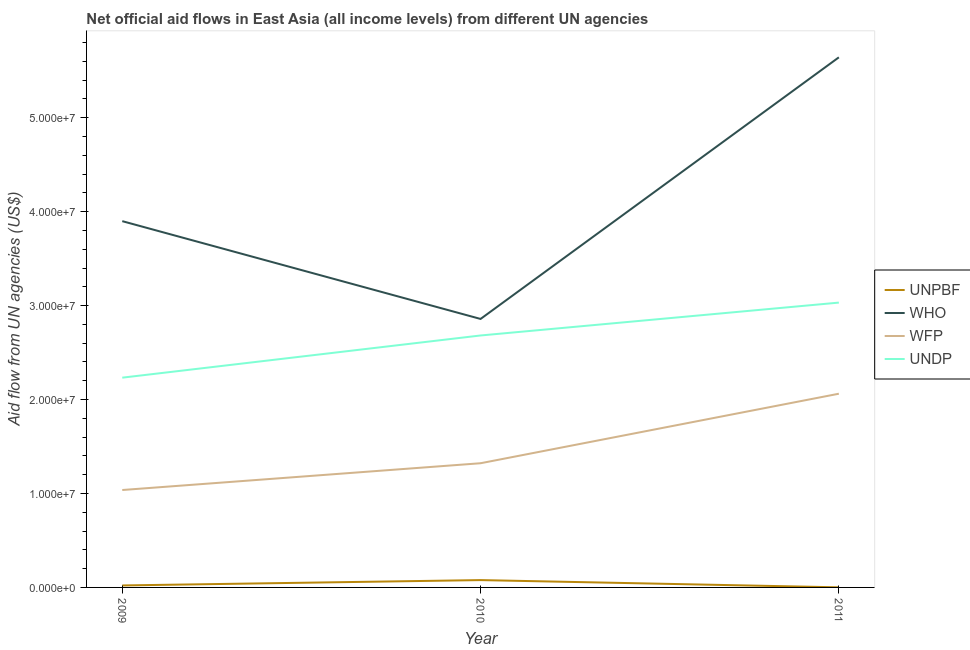Is the number of lines equal to the number of legend labels?
Your answer should be compact. Yes. What is the amount of aid given by wfp in 2011?
Offer a very short reply. 2.06e+07. Across all years, what is the maximum amount of aid given by who?
Provide a short and direct response. 5.64e+07. Across all years, what is the minimum amount of aid given by undp?
Make the answer very short. 2.23e+07. In which year was the amount of aid given by unpbf minimum?
Provide a short and direct response. 2011. What is the total amount of aid given by wfp in the graph?
Keep it short and to the point. 4.42e+07. What is the difference between the amount of aid given by unpbf in 2009 and that in 2011?
Keep it short and to the point. 2.00e+05. What is the difference between the amount of aid given by undp in 2009 and the amount of aid given by who in 2010?
Give a very brief answer. -6.25e+06. What is the average amount of aid given by unpbf per year?
Your response must be concise. 3.33e+05. In the year 2009, what is the difference between the amount of aid given by who and amount of aid given by unpbf?
Give a very brief answer. 3.88e+07. In how many years, is the amount of aid given by unpbf greater than 44000000 US$?
Give a very brief answer. 0. What is the ratio of the amount of aid given by who in 2009 to that in 2011?
Your response must be concise. 0.69. Is the amount of aid given by wfp in 2009 less than that in 2011?
Ensure brevity in your answer.  Yes. Is the difference between the amount of aid given by wfp in 2009 and 2011 greater than the difference between the amount of aid given by unpbf in 2009 and 2011?
Provide a succinct answer. No. What is the difference between the highest and the second highest amount of aid given by who?
Ensure brevity in your answer.  1.74e+07. What is the difference between the highest and the lowest amount of aid given by undp?
Make the answer very short. 7.99e+06. Is it the case that in every year, the sum of the amount of aid given by unpbf and amount of aid given by undp is greater than the sum of amount of aid given by who and amount of aid given by wfp?
Provide a short and direct response. Yes. Is it the case that in every year, the sum of the amount of aid given by unpbf and amount of aid given by who is greater than the amount of aid given by wfp?
Give a very brief answer. Yes. How many years are there in the graph?
Give a very brief answer. 3. What is the difference between two consecutive major ticks on the Y-axis?
Keep it short and to the point. 1.00e+07. Are the values on the major ticks of Y-axis written in scientific E-notation?
Ensure brevity in your answer.  Yes. Does the graph contain grids?
Offer a very short reply. No. Where does the legend appear in the graph?
Provide a succinct answer. Center right. How many legend labels are there?
Provide a succinct answer. 4. What is the title of the graph?
Your answer should be compact. Net official aid flows in East Asia (all income levels) from different UN agencies. What is the label or title of the X-axis?
Make the answer very short. Year. What is the label or title of the Y-axis?
Your response must be concise. Aid flow from UN agencies (US$). What is the Aid flow from UN agencies (US$) in WHO in 2009?
Provide a succinct answer. 3.90e+07. What is the Aid flow from UN agencies (US$) of WFP in 2009?
Provide a succinct answer. 1.04e+07. What is the Aid flow from UN agencies (US$) of UNDP in 2009?
Make the answer very short. 2.23e+07. What is the Aid flow from UN agencies (US$) in UNPBF in 2010?
Provide a short and direct response. 7.80e+05. What is the Aid flow from UN agencies (US$) of WHO in 2010?
Offer a very short reply. 2.86e+07. What is the Aid flow from UN agencies (US$) of WFP in 2010?
Your answer should be very brief. 1.32e+07. What is the Aid flow from UN agencies (US$) in UNDP in 2010?
Keep it short and to the point. 2.68e+07. What is the Aid flow from UN agencies (US$) of WHO in 2011?
Offer a very short reply. 5.64e+07. What is the Aid flow from UN agencies (US$) in WFP in 2011?
Offer a very short reply. 2.06e+07. What is the Aid flow from UN agencies (US$) of UNDP in 2011?
Provide a succinct answer. 3.03e+07. Across all years, what is the maximum Aid flow from UN agencies (US$) in UNPBF?
Offer a very short reply. 7.80e+05. Across all years, what is the maximum Aid flow from UN agencies (US$) in WHO?
Provide a short and direct response. 5.64e+07. Across all years, what is the maximum Aid flow from UN agencies (US$) of WFP?
Make the answer very short. 2.06e+07. Across all years, what is the maximum Aid flow from UN agencies (US$) of UNDP?
Provide a succinct answer. 3.03e+07. Across all years, what is the minimum Aid flow from UN agencies (US$) in UNPBF?
Provide a short and direct response. 10000. Across all years, what is the minimum Aid flow from UN agencies (US$) in WHO?
Make the answer very short. 2.86e+07. Across all years, what is the minimum Aid flow from UN agencies (US$) of WFP?
Your response must be concise. 1.04e+07. Across all years, what is the minimum Aid flow from UN agencies (US$) of UNDP?
Offer a very short reply. 2.23e+07. What is the total Aid flow from UN agencies (US$) of WHO in the graph?
Your answer should be compact. 1.24e+08. What is the total Aid flow from UN agencies (US$) in WFP in the graph?
Keep it short and to the point. 4.42e+07. What is the total Aid flow from UN agencies (US$) in UNDP in the graph?
Give a very brief answer. 7.95e+07. What is the difference between the Aid flow from UN agencies (US$) in UNPBF in 2009 and that in 2010?
Provide a short and direct response. -5.70e+05. What is the difference between the Aid flow from UN agencies (US$) in WHO in 2009 and that in 2010?
Your answer should be very brief. 1.04e+07. What is the difference between the Aid flow from UN agencies (US$) of WFP in 2009 and that in 2010?
Ensure brevity in your answer.  -2.85e+06. What is the difference between the Aid flow from UN agencies (US$) of UNDP in 2009 and that in 2010?
Provide a succinct answer. -4.49e+06. What is the difference between the Aid flow from UN agencies (US$) in UNPBF in 2009 and that in 2011?
Give a very brief answer. 2.00e+05. What is the difference between the Aid flow from UN agencies (US$) in WHO in 2009 and that in 2011?
Your response must be concise. -1.74e+07. What is the difference between the Aid flow from UN agencies (US$) in WFP in 2009 and that in 2011?
Keep it short and to the point. -1.02e+07. What is the difference between the Aid flow from UN agencies (US$) in UNDP in 2009 and that in 2011?
Provide a succinct answer. -7.99e+06. What is the difference between the Aid flow from UN agencies (US$) in UNPBF in 2010 and that in 2011?
Provide a short and direct response. 7.70e+05. What is the difference between the Aid flow from UN agencies (US$) of WHO in 2010 and that in 2011?
Keep it short and to the point. -2.78e+07. What is the difference between the Aid flow from UN agencies (US$) of WFP in 2010 and that in 2011?
Provide a short and direct response. -7.40e+06. What is the difference between the Aid flow from UN agencies (US$) of UNDP in 2010 and that in 2011?
Your response must be concise. -3.50e+06. What is the difference between the Aid flow from UN agencies (US$) in UNPBF in 2009 and the Aid flow from UN agencies (US$) in WHO in 2010?
Keep it short and to the point. -2.84e+07. What is the difference between the Aid flow from UN agencies (US$) in UNPBF in 2009 and the Aid flow from UN agencies (US$) in WFP in 2010?
Provide a succinct answer. -1.30e+07. What is the difference between the Aid flow from UN agencies (US$) of UNPBF in 2009 and the Aid flow from UN agencies (US$) of UNDP in 2010?
Your answer should be very brief. -2.66e+07. What is the difference between the Aid flow from UN agencies (US$) of WHO in 2009 and the Aid flow from UN agencies (US$) of WFP in 2010?
Your answer should be very brief. 2.58e+07. What is the difference between the Aid flow from UN agencies (US$) of WHO in 2009 and the Aid flow from UN agencies (US$) of UNDP in 2010?
Provide a short and direct response. 1.22e+07. What is the difference between the Aid flow from UN agencies (US$) in WFP in 2009 and the Aid flow from UN agencies (US$) in UNDP in 2010?
Ensure brevity in your answer.  -1.64e+07. What is the difference between the Aid flow from UN agencies (US$) of UNPBF in 2009 and the Aid flow from UN agencies (US$) of WHO in 2011?
Your answer should be very brief. -5.62e+07. What is the difference between the Aid flow from UN agencies (US$) of UNPBF in 2009 and the Aid flow from UN agencies (US$) of WFP in 2011?
Provide a short and direct response. -2.04e+07. What is the difference between the Aid flow from UN agencies (US$) in UNPBF in 2009 and the Aid flow from UN agencies (US$) in UNDP in 2011?
Offer a terse response. -3.01e+07. What is the difference between the Aid flow from UN agencies (US$) of WHO in 2009 and the Aid flow from UN agencies (US$) of WFP in 2011?
Provide a short and direct response. 1.84e+07. What is the difference between the Aid flow from UN agencies (US$) of WHO in 2009 and the Aid flow from UN agencies (US$) of UNDP in 2011?
Make the answer very short. 8.67e+06. What is the difference between the Aid flow from UN agencies (US$) in WFP in 2009 and the Aid flow from UN agencies (US$) in UNDP in 2011?
Provide a succinct answer. -2.00e+07. What is the difference between the Aid flow from UN agencies (US$) of UNPBF in 2010 and the Aid flow from UN agencies (US$) of WHO in 2011?
Your answer should be compact. -5.56e+07. What is the difference between the Aid flow from UN agencies (US$) in UNPBF in 2010 and the Aid flow from UN agencies (US$) in WFP in 2011?
Make the answer very short. -1.98e+07. What is the difference between the Aid flow from UN agencies (US$) of UNPBF in 2010 and the Aid flow from UN agencies (US$) of UNDP in 2011?
Make the answer very short. -2.95e+07. What is the difference between the Aid flow from UN agencies (US$) of WHO in 2010 and the Aid flow from UN agencies (US$) of WFP in 2011?
Provide a succinct answer. 7.96e+06. What is the difference between the Aid flow from UN agencies (US$) of WHO in 2010 and the Aid flow from UN agencies (US$) of UNDP in 2011?
Your response must be concise. -1.74e+06. What is the difference between the Aid flow from UN agencies (US$) of WFP in 2010 and the Aid flow from UN agencies (US$) of UNDP in 2011?
Keep it short and to the point. -1.71e+07. What is the average Aid flow from UN agencies (US$) of UNPBF per year?
Offer a very short reply. 3.33e+05. What is the average Aid flow from UN agencies (US$) in WHO per year?
Provide a short and direct response. 4.13e+07. What is the average Aid flow from UN agencies (US$) of WFP per year?
Your answer should be very brief. 1.47e+07. What is the average Aid flow from UN agencies (US$) in UNDP per year?
Your answer should be compact. 2.65e+07. In the year 2009, what is the difference between the Aid flow from UN agencies (US$) in UNPBF and Aid flow from UN agencies (US$) in WHO?
Provide a succinct answer. -3.88e+07. In the year 2009, what is the difference between the Aid flow from UN agencies (US$) of UNPBF and Aid flow from UN agencies (US$) of WFP?
Keep it short and to the point. -1.02e+07. In the year 2009, what is the difference between the Aid flow from UN agencies (US$) in UNPBF and Aid flow from UN agencies (US$) in UNDP?
Offer a very short reply. -2.21e+07. In the year 2009, what is the difference between the Aid flow from UN agencies (US$) in WHO and Aid flow from UN agencies (US$) in WFP?
Ensure brevity in your answer.  2.86e+07. In the year 2009, what is the difference between the Aid flow from UN agencies (US$) of WHO and Aid flow from UN agencies (US$) of UNDP?
Your answer should be very brief. 1.67e+07. In the year 2009, what is the difference between the Aid flow from UN agencies (US$) of WFP and Aid flow from UN agencies (US$) of UNDP?
Offer a very short reply. -1.20e+07. In the year 2010, what is the difference between the Aid flow from UN agencies (US$) in UNPBF and Aid flow from UN agencies (US$) in WHO?
Offer a terse response. -2.78e+07. In the year 2010, what is the difference between the Aid flow from UN agencies (US$) of UNPBF and Aid flow from UN agencies (US$) of WFP?
Your response must be concise. -1.24e+07. In the year 2010, what is the difference between the Aid flow from UN agencies (US$) in UNPBF and Aid flow from UN agencies (US$) in UNDP?
Offer a terse response. -2.60e+07. In the year 2010, what is the difference between the Aid flow from UN agencies (US$) of WHO and Aid flow from UN agencies (US$) of WFP?
Your answer should be compact. 1.54e+07. In the year 2010, what is the difference between the Aid flow from UN agencies (US$) of WHO and Aid flow from UN agencies (US$) of UNDP?
Ensure brevity in your answer.  1.76e+06. In the year 2010, what is the difference between the Aid flow from UN agencies (US$) of WFP and Aid flow from UN agencies (US$) of UNDP?
Provide a short and direct response. -1.36e+07. In the year 2011, what is the difference between the Aid flow from UN agencies (US$) in UNPBF and Aid flow from UN agencies (US$) in WHO?
Ensure brevity in your answer.  -5.64e+07. In the year 2011, what is the difference between the Aid flow from UN agencies (US$) in UNPBF and Aid flow from UN agencies (US$) in WFP?
Provide a succinct answer. -2.06e+07. In the year 2011, what is the difference between the Aid flow from UN agencies (US$) in UNPBF and Aid flow from UN agencies (US$) in UNDP?
Your answer should be compact. -3.03e+07. In the year 2011, what is the difference between the Aid flow from UN agencies (US$) in WHO and Aid flow from UN agencies (US$) in WFP?
Provide a short and direct response. 3.58e+07. In the year 2011, what is the difference between the Aid flow from UN agencies (US$) in WHO and Aid flow from UN agencies (US$) in UNDP?
Your answer should be compact. 2.61e+07. In the year 2011, what is the difference between the Aid flow from UN agencies (US$) in WFP and Aid flow from UN agencies (US$) in UNDP?
Keep it short and to the point. -9.70e+06. What is the ratio of the Aid flow from UN agencies (US$) of UNPBF in 2009 to that in 2010?
Offer a very short reply. 0.27. What is the ratio of the Aid flow from UN agencies (US$) in WHO in 2009 to that in 2010?
Give a very brief answer. 1.36. What is the ratio of the Aid flow from UN agencies (US$) of WFP in 2009 to that in 2010?
Keep it short and to the point. 0.78. What is the ratio of the Aid flow from UN agencies (US$) of UNDP in 2009 to that in 2010?
Your answer should be compact. 0.83. What is the ratio of the Aid flow from UN agencies (US$) of UNPBF in 2009 to that in 2011?
Offer a very short reply. 21. What is the ratio of the Aid flow from UN agencies (US$) in WHO in 2009 to that in 2011?
Ensure brevity in your answer.  0.69. What is the ratio of the Aid flow from UN agencies (US$) of WFP in 2009 to that in 2011?
Your answer should be compact. 0.5. What is the ratio of the Aid flow from UN agencies (US$) in UNDP in 2009 to that in 2011?
Give a very brief answer. 0.74. What is the ratio of the Aid flow from UN agencies (US$) in WHO in 2010 to that in 2011?
Your answer should be compact. 0.51. What is the ratio of the Aid flow from UN agencies (US$) of WFP in 2010 to that in 2011?
Provide a short and direct response. 0.64. What is the ratio of the Aid flow from UN agencies (US$) in UNDP in 2010 to that in 2011?
Ensure brevity in your answer.  0.88. What is the difference between the highest and the second highest Aid flow from UN agencies (US$) in UNPBF?
Your answer should be compact. 5.70e+05. What is the difference between the highest and the second highest Aid flow from UN agencies (US$) in WHO?
Your response must be concise. 1.74e+07. What is the difference between the highest and the second highest Aid flow from UN agencies (US$) of WFP?
Keep it short and to the point. 7.40e+06. What is the difference between the highest and the second highest Aid flow from UN agencies (US$) in UNDP?
Your response must be concise. 3.50e+06. What is the difference between the highest and the lowest Aid flow from UN agencies (US$) of UNPBF?
Your answer should be very brief. 7.70e+05. What is the difference between the highest and the lowest Aid flow from UN agencies (US$) in WHO?
Provide a succinct answer. 2.78e+07. What is the difference between the highest and the lowest Aid flow from UN agencies (US$) in WFP?
Your answer should be compact. 1.02e+07. What is the difference between the highest and the lowest Aid flow from UN agencies (US$) in UNDP?
Offer a terse response. 7.99e+06. 